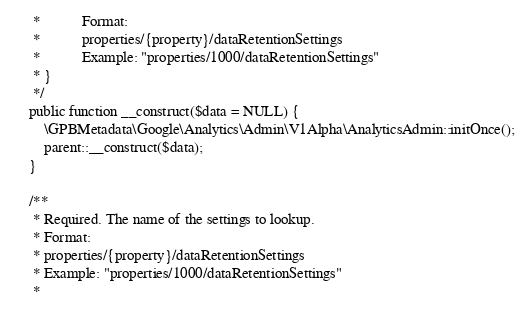Convert code to text. <code><loc_0><loc_0><loc_500><loc_500><_PHP_>     *           Format:
     *           properties/{property}/dataRetentionSettings
     *           Example: "properties/1000/dataRetentionSettings"
     * }
     */
    public function __construct($data = NULL) {
        \GPBMetadata\Google\Analytics\Admin\V1Alpha\AnalyticsAdmin::initOnce();
        parent::__construct($data);
    }

    /**
     * Required. The name of the settings to lookup.
     * Format:
     * properties/{property}/dataRetentionSettings
     * Example: "properties/1000/dataRetentionSettings"
     *</code> 